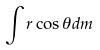<formula> <loc_0><loc_0><loc_500><loc_500>\int r \cos \theta d m</formula> 